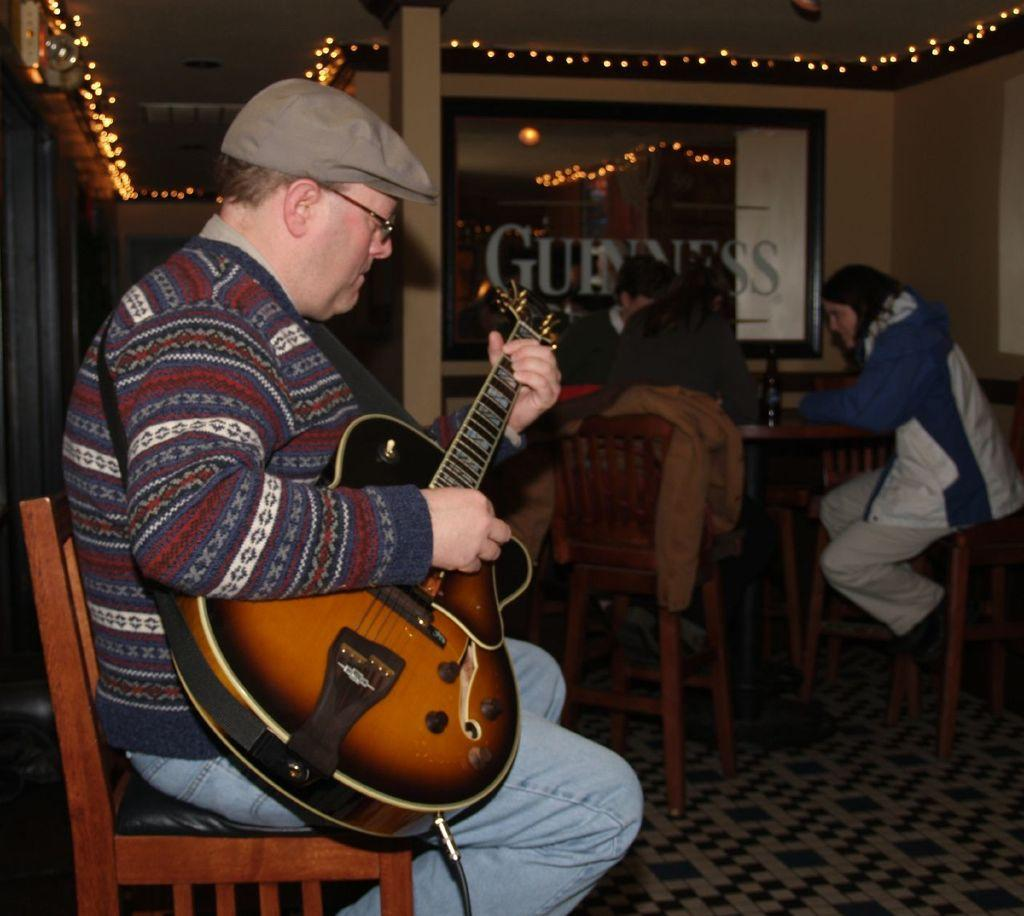What is the man in the image doing? The man is sitting on a bench in the image. What is the man holding in the image? The man is holding a guitar. Can you describe the people visible in the image? There are people visible in the image. What can be seen in the image that provides light? There is light in the image. What type of architectural feature can be seen in the background of the image? There appears to be a glass window in the background of the image. How many snakes are crawling on the man's guitar in the image? There are no snakes visible in the image; the man is holding a guitar, but there are no snakes present. 